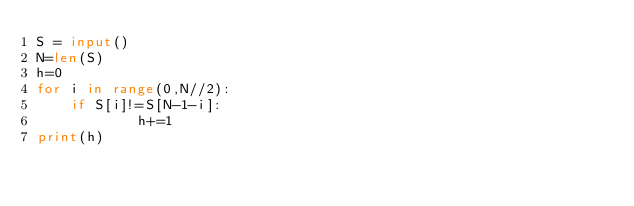Convert code to text. <code><loc_0><loc_0><loc_500><loc_500><_Python_>S = input() 
N=len(S)
h=0
for i in range(0,N//2):
    if S[i]!=S[N-1-i]:
            h+=1
print(h)</code> 